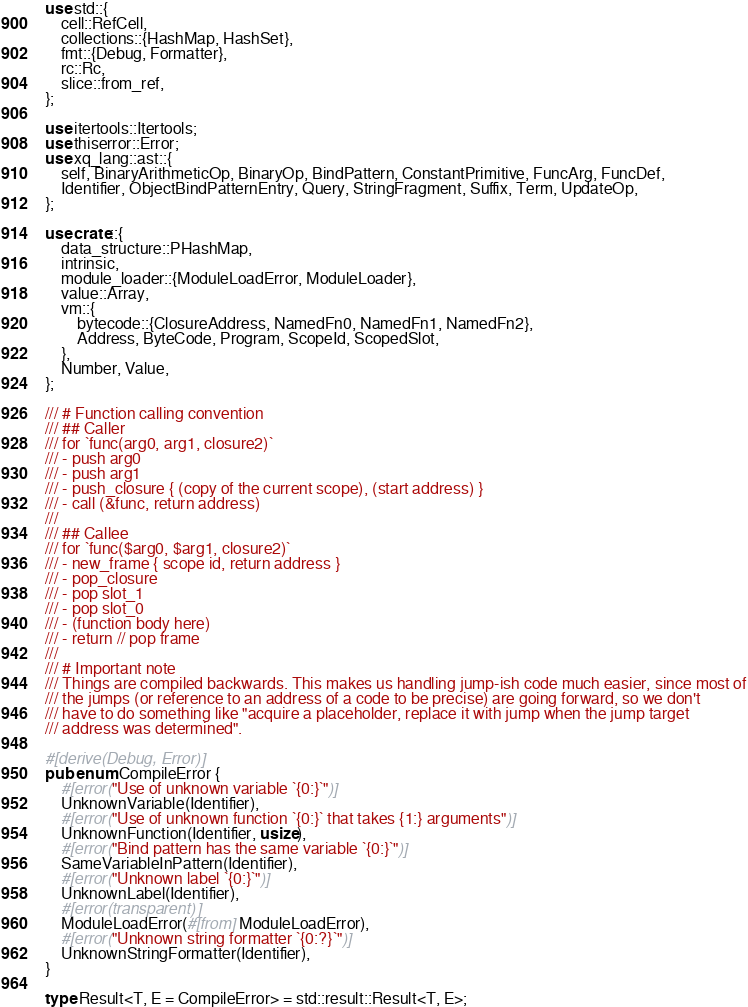<code> <loc_0><loc_0><loc_500><loc_500><_Rust_>use std::{
    cell::RefCell,
    collections::{HashMap, HashSet},
    fmt::{Debug, Formatter},
    rc::Rc,
    slice::from_ref,
};

use itertools::Itertools;
use thiserror::Error;
use xq_lang::ast::{
    self, BinaryArithmeticOp, BinaryOp, BindPattern, ConstantPrimitive, FuncArg, FuncDef,
    Identifier, ObjectBindPatternEntry, Query, StringFragment, Suffix, Term, UpdateOp,
};

use crate::{
    data_structure::PHashMap,
    intrinsic,
    module_loader::{ModuleLoadError, ModuleLoader},
    value::Array,
    vm::{
        bytecode::{ClosureAddress, NamedFn0, NamedFn1, NamedFn2},
        Address, ByteCode, Program, ScopeId, ScopedSlot,
    },
    Number, Value,
};

/// # Function calling convention
/// ## Caller
/// for `func(arg0, arg1, closure2)`
/// - push arg0
/// - push arg1
/// - push_closure { (copy of the current scope), (start address) }
/// - call (&func, return address)
///
/// ## Callee
/// for `func($arg0, $arg1, closure2)`
/// - new_frame { scope id, return address }
/// - pop_closure
/// - pop slot_1
/// - pop slot_0
/// - (function body here)
/// - return // pop frame
///
/// # Important note
/// Things are compiled backwards. This makes us handling jump-ish code much easier, since most of
/// the jumps (or reference to an address of a code to be precise) are going forward, so we don't
/// have to do something like "acquire a placeholder, replace it with jump when the jump target
/// address was determined".

#[derive(Debug, Error)]
pub enum CompileError {
    #[error("Use of unknown variable `{0:}`")]
    UnknownVariable(Identifier),
    #[error("Use of unknown function `{0:}` that takes {1:} arguments")]
    UnknownFunction(Identifier, usize),
    #[error("Bind pattern has the same variable `{0:}`")]
    SameVariableInPattern(Identifier),
    #[error("Unknown label `{0:}`")]
    UnknownLabel(Identifier),
    #[error(transparent)]
    ModuleLoadError(#[from] ModuleLoadError),
    #[error("Unknown string formatter `{0:?}`")]
    UnknownStringFormatter(Identifier),
}

type Result<T, E = CompileError> = std::result::Result<T, E>;
</code> 